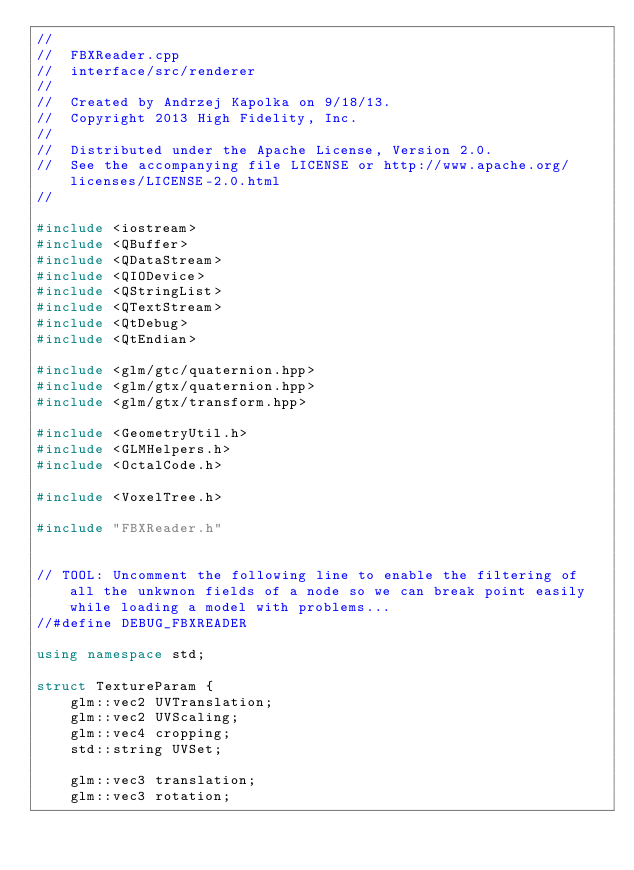Convert code to text. <code><loc_0><loc_0><loc_500><loc_500><_C++_>//
//  FBXReader.cpp
//  interface/src/renderer
//
//  Created by Andrzej Kapolka on 9/18/13.
//  Copyright 2013 High Fidelity, Inc.
//
//  Distributed under the Apache License, Version 2.0.
//  See the accompanying file LICENSE or http://www.apache.org/licenses/LICENSE-2.0.html
//

#include <iostream>
#include <QBuffer>
#include <QDataStream>
#include <QIODevice>
#include <QStringList>
#include <QTextStream>
#include <QtDebug>
#include <QtEndian>

#include <glm/gtc/quaternion.hpp>
#include <glm/gtx/quaternion.hpp>
#include <glm/gtx/transform.hpp>

#include <GeometryUtil.h>
#include <GLMHelpers.h>
#include <OctalCode.h>

#include <VoxelTree.h>

#include "FBXReader.h"


// TOOL: Uncomment the following line to enable the filtering of all the unkwnon fields of a node so we can break point easily while loading a model with problems...
//#define DEBUG_FBXREADER

using namespace std;

struct TextureParam {
    glm::vec2 UVTranslation;
    glm::vec2 UVScaling;
    glm::vec4 cropping;
    std::string UVSet;

    glm::vec3 translation;
    glm::vec3 rotation;</code> 